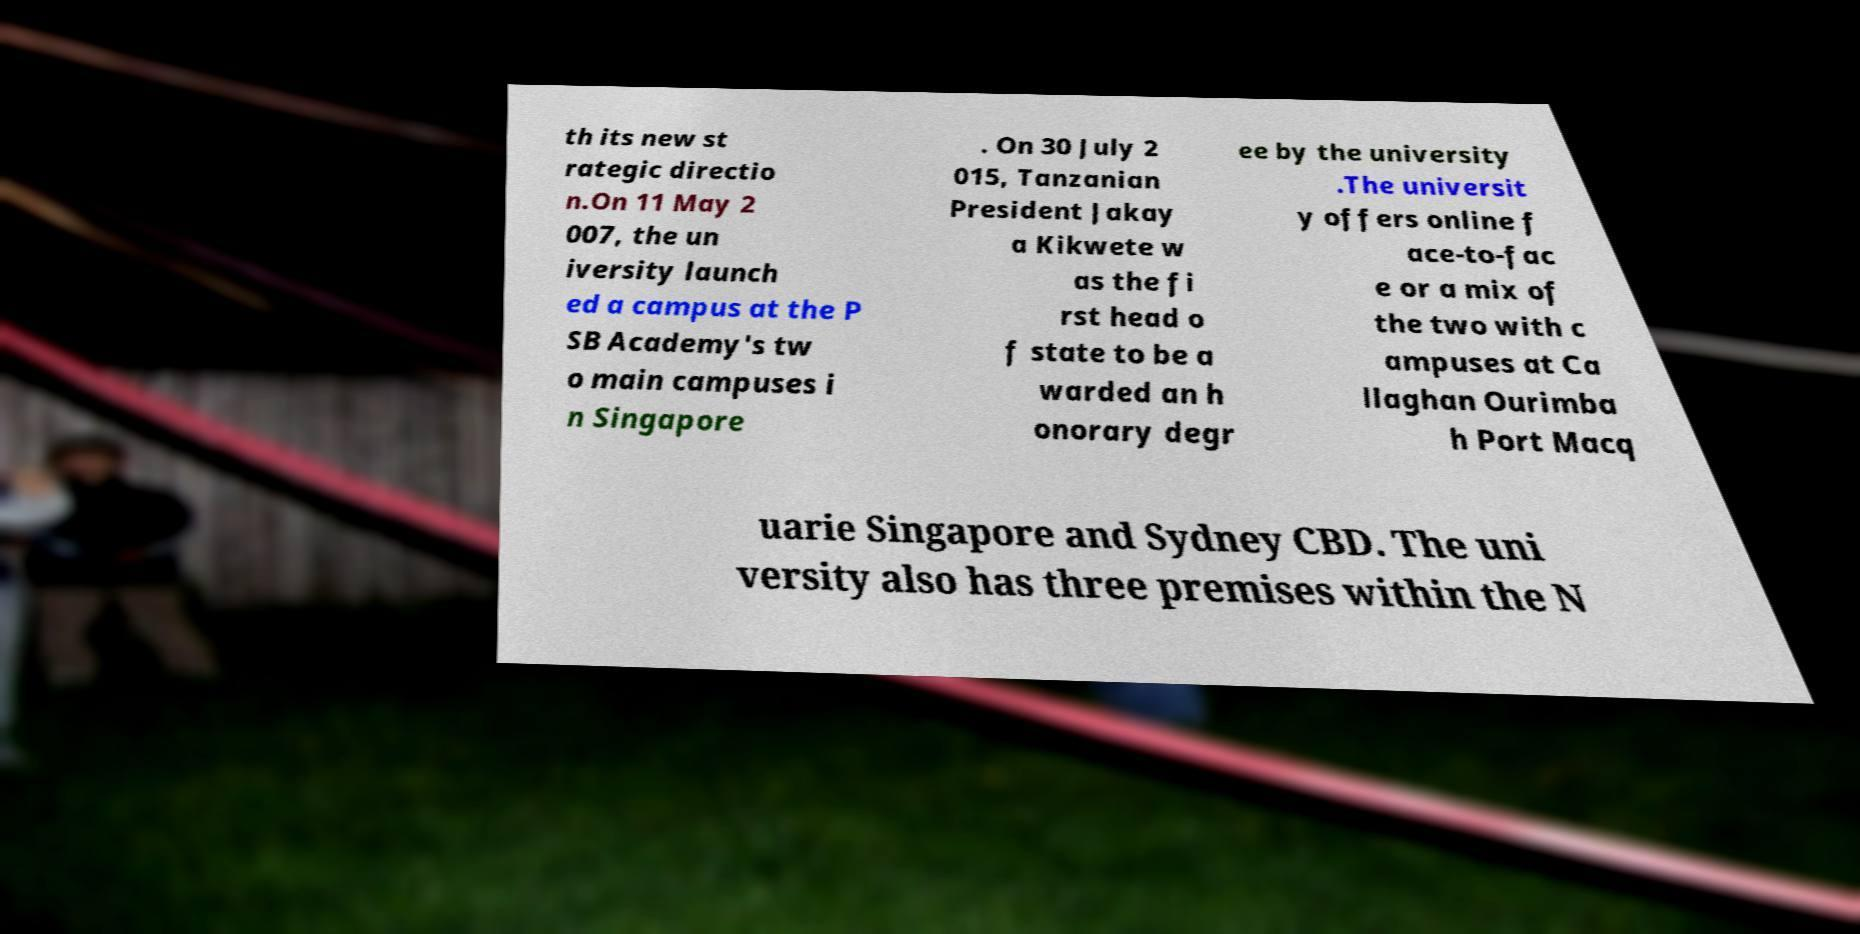What messages or text are displayed in this image? I need them in a readable, typed format. th its new st rategic directio n.On 11 May 2 007, the un iversity launch ed a campus at the P SB Academy's tw o main campuses i n Singapore . On 30 July 2 015, Tanzanian President Jakay a Kikwete w as the fi rst head o f state to be a warded an h onorary degr ee by the university .The universit y offers online f ace-to-fac e or a mix of the two with c ampuses at Ca llaghan Ourimba h Port Macq uarie Singapore and Sydney CBD. The uni versity also has three premises within the N 